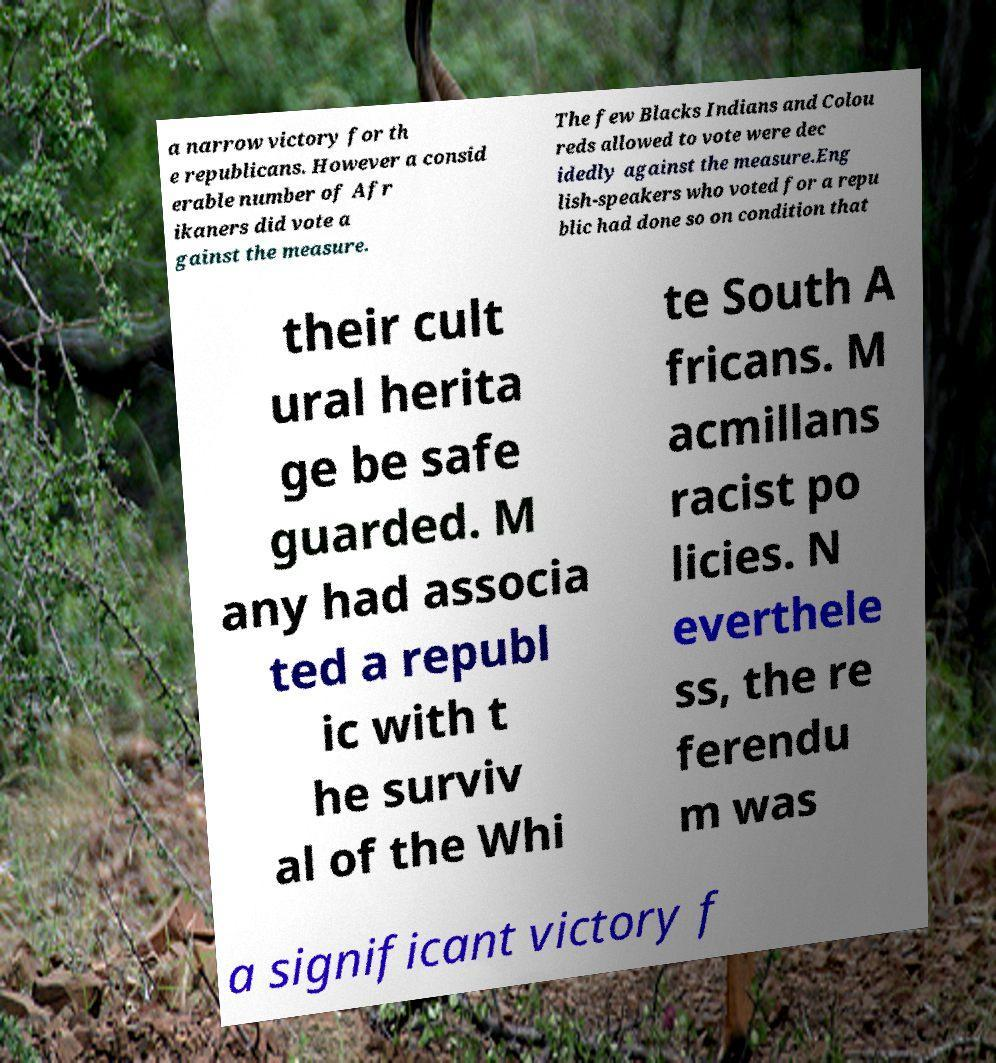What messages or text are displayed in this image? I need them in a readable, typed format. a narrow victory for th e republicans. However a consid erable number of Afr ikaners did vote a gainst the measure. The few Blacks Indians and Colou reds allowed to vote were dec idedly against the measure.Eng lish-speakers who voted for a repu blic had done so on condition that their cult ural herita ge be safe guarded. M any had associa ted a republ ic with t he surviv al of the Whi te South A fricans. M acmillans racist po licies. N everthele ss, the re ferendu m was a significant victory f 